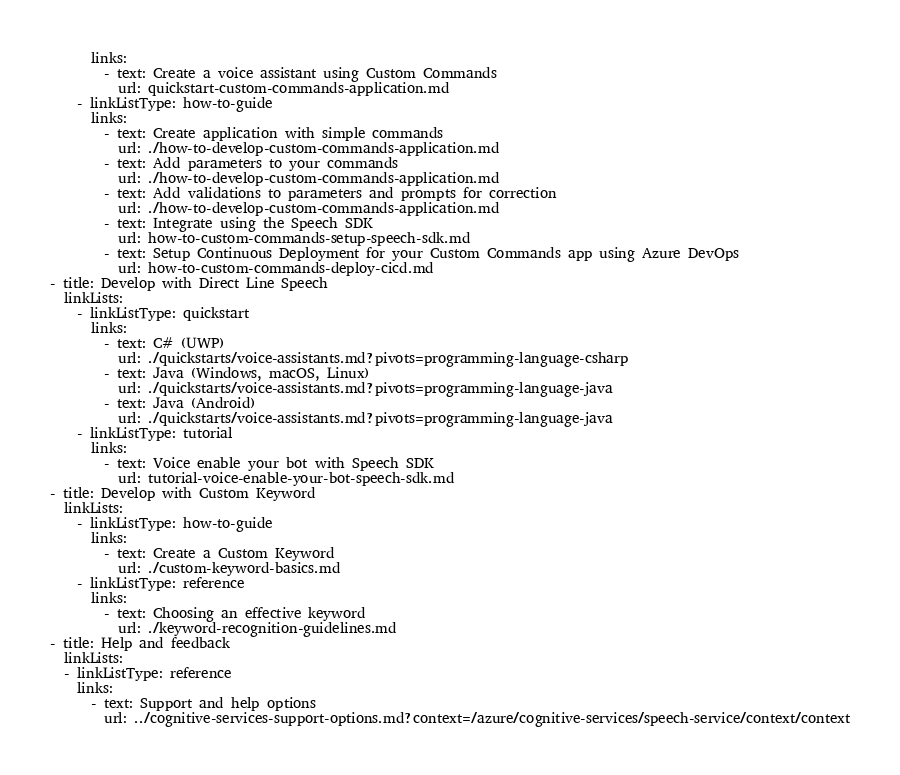Convert code to text. <code><loc_0><loc_0><loc_500><loc_500><_YAML_>      links:
        - text: Create a voice assistant using Custom Commands
          url: quickstart-custom-commands-application.md
    - linkListType: how-to-guide
      links:
        - text: Create application with simple commands
          url: ./how-to-develop-custom-commands-application.md
        - text: Add parameters to your commands
          url: ./how-to-develop-custom-commands-application.md
        - text: Add validations to parameters and prompts for correction
          url: ./how-to-develop-custom-commands-application.md
        - text: Integrate using the Speech SDK
          url: how-to-custom-commands-setup-speech-sdk.md
        - text: Setup Continuous Deployment for your Custom Commands app using Azure DevOps
          url: how-to-custom-commands-deploy-cicd.md
- title: Develop with Direct Line Speech
  linkLists:
    - linkListType: quickstart
      links:
        - text: C# (UWP)
          url: ./quickstarts/voice-assistants.md?pivots=programming-language-csharp
        - text: Java (Windows, macOS, Linux)
          url: ./quickstarts/voice-assistants.md?pivots=programming-language-java
        - text: Java (Android)
          url: ./quickstarts/voice-assistants.md?pivots=programming-language-java
    - linkListType: tutorial
      links:
        - text: Voice enable your bot with Speech SDK
          url: tutorial-voice-enable-your-bot-speech-sdk.md
- title: Develop with Custom Keyword
  linkLists:
    - linkListType: how-to-guide
      links:
        - text: Create a Custom Keyword
          url: ./custom-keyword-basics.md
    - linkListType: reference
      links:
        - text: Choosing an effective keyword
          url: ./keyword-recognition-guidelines.md
- title: Help and feedback
  linkLists:
  - linkListType: reference
    links:
      - text: Support and help options
        url: ../cognitive-services-support-options.md?context=/azure/cognitive-services/speech-service/context/context</code> 